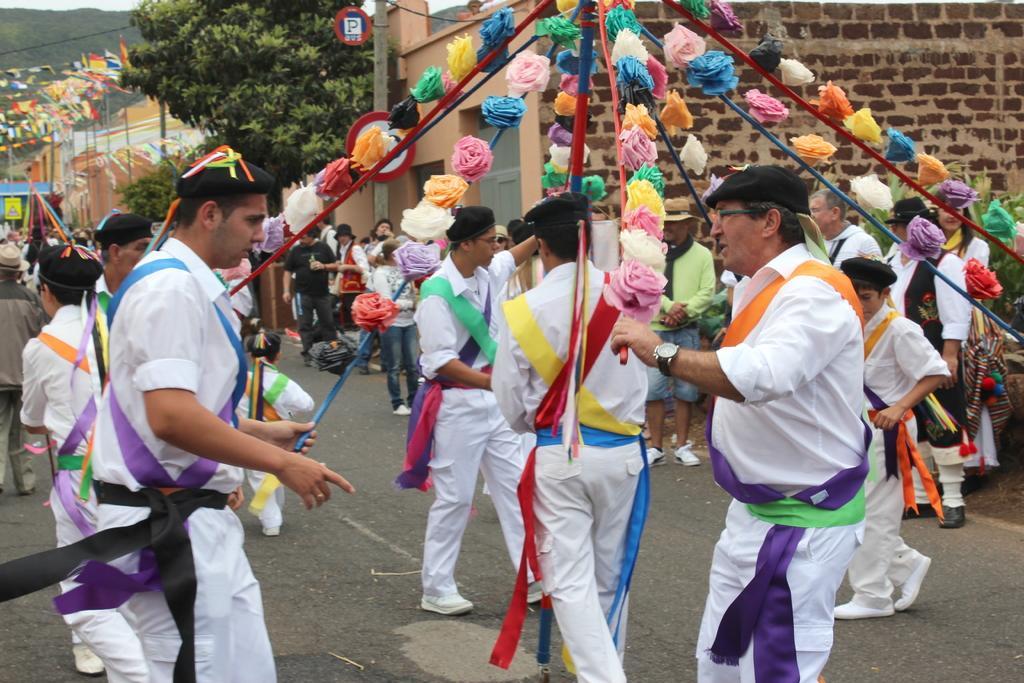How would you summarize this image in a sentence or two? As we can see in the image there are few people here and there, flower, houses, tree and the people in the front are wearing white color dresses. 